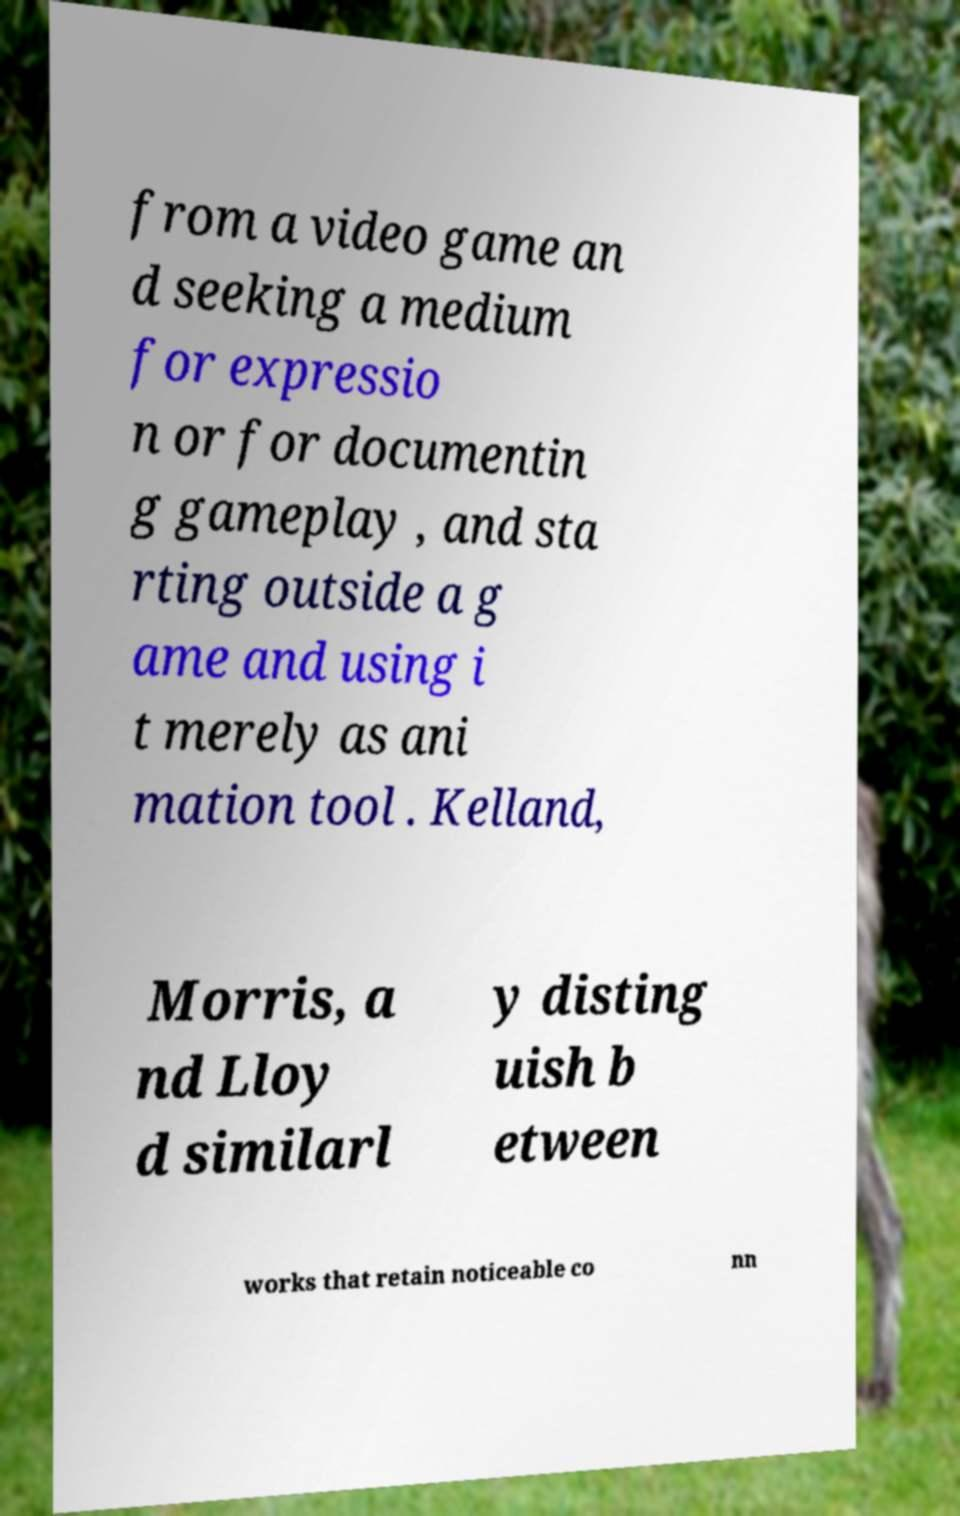Could you assist in decoding the text presented in this image and type it out clearly? from a video game an d seeking a medium for expressio n or for documentin g gameplay , and sta rting outside a g ame and using i t merely as ani mation tool . Kelland, Morris, a nd Lloy d similarl y disting uish b etween works that retain noticeable co nn 